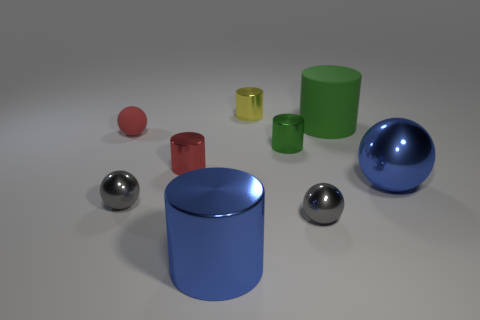What is the shape of the blue thing in front of the small gray object that is right of the big metallic thing to the left of the green rubber cylinder?
Provide a succinct answer. Cylinder. There is a big blue object that is to the right of the big blue cylinder; what shape is it?
Your answer should be very brief. Sphere. Are the small red ball and the big object behind the big metal sphere made of the same material?
Offer a terse response. Yes. How many other objects are the same shape as the yellow object?
Keep it short and to the point. 4. Is the color of the rubber sphere the same as the small cylinder that is to the left of the small yellow shiny cylinder?
Provide a succinct answer. Yes. What shape is the blue object on the right side of the large cylinder that is in front of the large metal ball?
Keep it short and to the point. Sphere. What size is the shiny cylinder that is the same color as the big rubber object?
Your answer should be compact. Small. Do the blue metal thing on the left side of the blue shiny ball and the tiny rubber object have the same shape?
Provide a succinct answer. No. Are there more tiny cylinders that are in front of the large green thing than yellow things in front of the big blue metallic ball?
Your answer should be very brief. Yes. There is a tiny metal ball that is right of the tiny yellow metallic thing; how many tiny metal things are to the left of it?
Offer a very short reply. 4. 